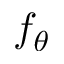<formula> <loc_0><loc_0><loc_500><loc_500>f _ { \theta }</formula> 